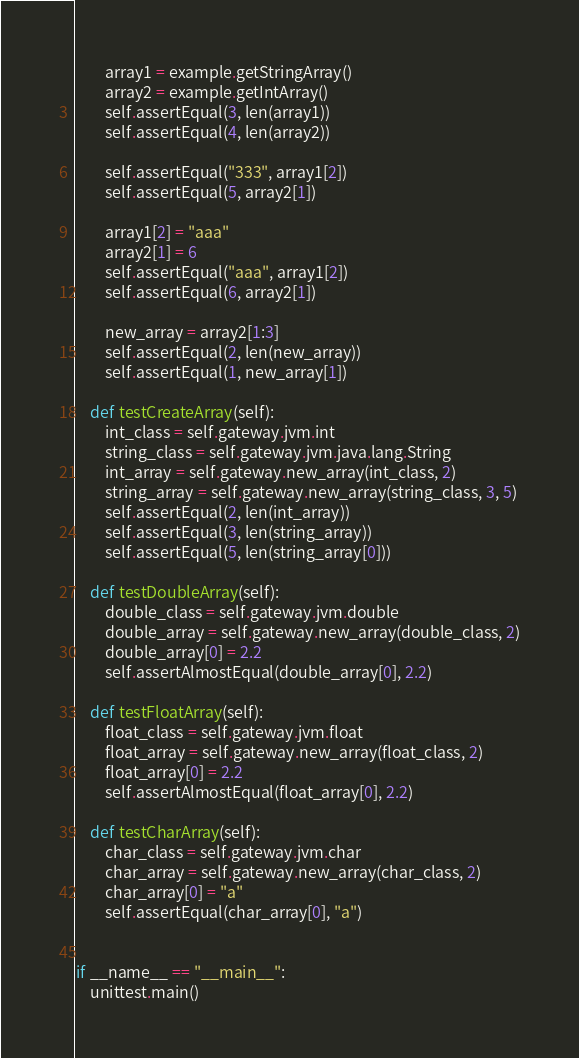<code> <loc_0><loc_0><loc_500><loc_500><_Python_>        array1 = example.getStringArray()
        array2 = example.getIntArray()
        self.assertEqual(3, len(array1))
        self.assertEqual(4, len(array2))

        self.assertEqual("333", array1[2])
        self.assertEqual(5, array2[1])

        array1[2] = "aaa"
        array2[1] = 6
        self.assertEqual("aaa", array1[2])
        self.assertEqual(6, array2[1])

        new_array = array2[1:3]
        self.assertEqual(2, len(new_array))
        self.assertEqual(1, new_array[1])

    def testCreateArray(self):
        int_class = self.gateway.jvm.int
        string_class = self.gateway.jvm.java.lang.String
        int_array = self.gateway.new_array(int_class, 2)
        string_array = self.gateway.new_array(string_class, 3, 5)
        self.assertEqual(2, len(int_array))
        self.assertEqual(3, len(string_array))
        self.assertEqual(5, len(string_array[0]))

    def testDoubleArray(self):
        double_class = self.gateway.jvm.double
        double_array = self.gateway.new_array(double_class, 2)
        double_array[0] = 2.2
        self.assertAlmostEqual(double_array[0], 2.2)

    def testFloatArray(self):
        float_class = self.gateway.jvm.float
        float_array = self.gateway.new_array(float_class, 2)
        float_array[0] = 2.2
        self.assertAlmostEqual(float_array[0], 2.2)

    def testCharArray(self):
        char_class = self.gateway.jvm.char
        char_array = self.gateway.new_array(char_class, 2)
        char_array[0] = "a"
        self.assertEqual(char_array[0], "a")


if __name__ == "__main__":
    unittest.main()
</code> 